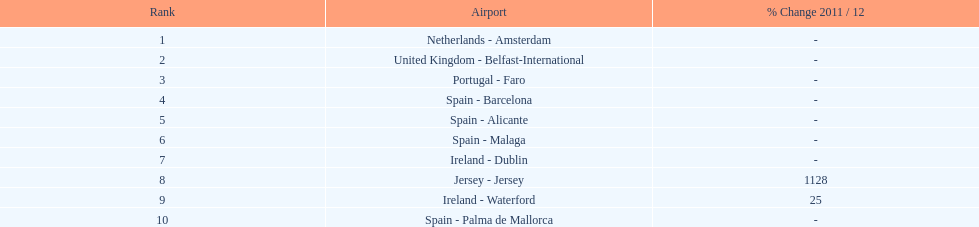How many passengers were handled in an airport in spain? 217,548. 